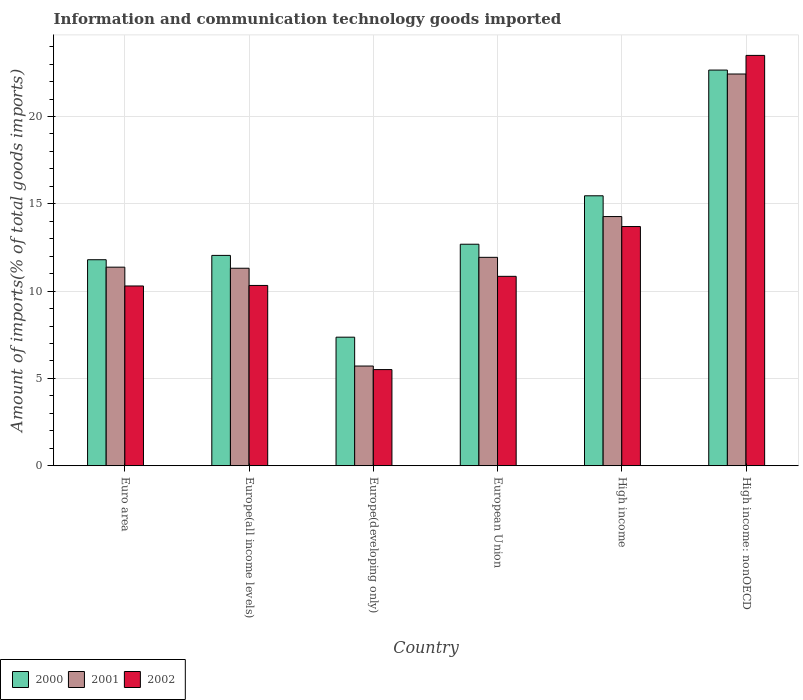How many groups of bars are there?
Provide a short and direct response. 6. Are the number of bars per tick equal to the number of legend labels?
Keep it short and to the point. Yes. Are the number of bars on each tick of the X-axis equal?
Make the answer very short. Yes. How many bars are there on the 6th tick from the right?
Offer a terse response. 3. What is the label of the 5th group of bars from the left?
Your answer should be compact. High income. In how many cases, is the number of bars for a given country not equal to the number of legend labels?
Your answer should be very brief. 0. What is the amount of goods imported in 2001 in High income: nonOECD?
Keep it short and to the point. 22.43. Across all countries, what is the maximum amount of goods imported in 2000?
Your response must be concise. 22.66. Across all countries, what is the minimum amount of goods imported in 2001?
Your answer should be very brief. 5.71. In which country was the amount of goods imported in 2000 maximum?
Offer a very short reply. High income: nonOECD. In which country was the amount of goods imported in 2000 minimum?
Your answer should be compact. Europe(developing only). What is the total amount of goods imported in 2002 in the graph?
Keep it short and to the point. 74.17. What is the difference between the amount of goods imported in 2000 in Euro area and that in Europe(all income levels)?
Give a very brief answer. -0.25. What is the difference between the amount of goods imported in 2001 in European Union and the amount of goods imported in 2000 in Europe(developing only)?
Offer a terse response. 4.57. What is the average amount of goods imported in 2000 per country?
Offer a terse response. 13.67. What is the difference between the amount of goods imported of/in 2001 and amount of goods imported of/in 2002 in Euro area?
Provide a succinct answer. 1.08. What is the ratio of the amount of goods imported in 2001 in Europe(developing only) to that in High income?
Provide a short and direct response. 0.4. Is the difference between the amount of goods imported in 2001 in Europe(all income levels) and High income greater than the difference between the amount of goods imported in 2002 in Europe(all income levels) and High income?
Offer a very short reply. Yes. What is the difference between the highest and the second highest amount of goods imported in 2001?
Your answer should be very brief. -10.5. What is the difference between the highest and the lowest amount of goods imported in 2000?
Offer a very short reply. 15.3. What does the 2nd bar from the left in High income: nonOECD represents?
Your response must be concise. 2001. Is it the case that in every country, the sum of the amount of goods imported in 2002 and amount of goods imported in 2000 is greater than the amount of goods imported in 2001?
Provide a succinct answer. Yes. Are all the bars in the graph horizontal?
Offer a terse response. No. What is the difference between two consecutive major ticks on the Y-axis?
Offer a terse response. 5. Does the graph contain grids?
Keep it short and to the point. Yes. Where does the legend appear in the graph?
Provide a short and direct response. Bottom left. How many legend labels are there?
Give a very brief answer. 3. How are the legend labels stacked?
Make the answer very short. Horizontal. What is the title of the graph?
Provide a short and direct response. Information and communication technology goods imported. What is the label or title of the Y-axis?
Give a very brief answer. Amount of imports(% of total goods imports). What is the Amount of imports(% of total goods imports) of 2000 in Euro area?
Offer a very short reply. 11.8. What is the Amount of imports(% of total goods imports) of 2001 in Euro area?
Your answer should be very brief. 11.37. What is the Amount of imports(% of total goods imports) in 2002 in Euro area?
Provide a succinct answer. 10.29. What is the Amount of imports(% of total goods imports) in 2000 in Europe(all income levels)?
Ensure brevity in your answer.  12.04. What is the Amount of imports(% of total goods imports) of 2001 in Europe(all income levels)?
Offer a very short reply. 11.31. What is the Amount of imports(% of total goods imports) of 2002 in Europe(all income levels)?
Your response must be concise. 10.32. What is the Amount of imports(% of total goods imports) in 2000 in Europe(developing only)?
Ensure brevity in your answer.  7.36. What is the Amount of imports(% of total goods imports) in 2001 in Europe(developing only)?
Make the answer very short. 5.71. What is the Amount of imports(% of total goods imports) of 2002 in Europe(developing only)?
Make the answer very short. 5.51. What is the Amount of imports(% of total goods imports) of 2000 in European Union?
Make the answer very short. 12.68. What is the Amount of imports(% of total goods imports) of 2001 in European Union?
Provide a short and direct response. 11.93. What is the Amount of imports(% of total goods imports) of 2002 in European Union?
Provide a succinct answer. 10.85. What is the Amount of imports(% of total goods imports) of 2000 in High income?
Your answer should be very brief. 15.46. What is the Amount of imports(% of total goods imports) in 2001 in High income?
Offer a very short reply. 14.27. What is the Amount of imports(% of total goods imports) in 2002 in High income?
Your answer should be compact. 13.7. What is the Amount of imports(% of total goods imports) of 2000 in High income: nonOECD?
Make the answer very short. 22.66. What is the Amount of imports(% of total goods imports) of 2001 in High income: nonOECD?
Offer a very short reply. 22.43. What is the Amount of imports(% of total goods imports) of 2002 in High income: nonOECD?
Provide a short and direct response. 23.5. Across all countries, what is the maximum Amount of imports(% of total goods imports) in 2000?
Your answer should be very brief. 22.66. Across all countries, what is the maximum Amount of imports(% of total goods imports) of 2001?
Your answer should be very brief. 22.43. Across all countries, what is the maximum Amount of imports(% of total goods imports) of 2002?
Ensure brevity in your answer.  23.5. Across all countries, what is the minimum Amount of imports(% of total goods imports) of 2000?
Provide a short and direct response. 7.36. Across all countries, what is the minimum Amount of imports(% of total goods imports) in 2001?
Make the answer very short. 5.71. Across all countries, what is the minimum Amount of imports(% of total goods imports) in 2002?
Keep it short and to the point. 5.51. What is the total Amount of imports(% of total goods imports) of 2000 in the graph?
Ensure brevity in your answer.  82.01. What is the total Amount of imports(% of total goods imports) of 2001 in the graph?
Make the answer very short. 77.03. What is the total Amount of imports(% of total goods imports) of 2002 in the graph?
Your answer should be very brief. 74.17. What is the difference between the Amount of imports(% of total goods imports) in 2000 in Euro area and that in Europe(all income levels)?
Ensure brevity in your answer.  -0.25. What is the difference between the Amount of imports(% of total goods imports) in 2001 in Euro area and that in Europe(all income levels)?
Your answer should be compact. 0.06. What is the difference between the Amount of imports(% of total goods imports) in 2002 in Euro area and that in Europe(all income levels)?
Ensure brevity in your answer.  -0.03. What is the difference between the Amount of imports(% of total goods imports) in 2000 in Euro area and that in Europe(developing only)?
Your answer should be very brief. 4.44. What is the difference between the Amount of imports(% of total goods imports) of 2001 in Euro area and that in Europe(developing only)?
Offer a very short reply. 5.66. What is the difference between the Amount of imports(% of total goods imports) in 2002 in Euro area and that in Europe(developing only)?
Your answer should be very brief. 4.79. What is the difference between the Amount of imports(% of total goods imports) in 2000 in Euro area and that in European Union?
Your answer should be very brief. -0.89. What is the difference between the Amount of imports(% of total goods imports) in 2001 in Euro area and that in European Union?
Offer a terse response. -0.56. What is the difference between the Amount of imports(% of total goods imports) of 2002 in Euro area and that in European Union?
Give a very brief answer. -0.55. What is the difference between the Amount of imports(% of total goods imports) of 2000 in Euro area and that in High income?
Keep it short and to the point. -3.66. What is the difference between the Amount of imports(% of total goods imports) of 2001 in Euro area and that in High income?
Give a very brief answer. -2.9. What is the difference between the Amount of imports(% of total goods imports) of 2002 in Euro area and that in High income?
Your response must be concise. -3.4. What is the difference between the Amount of imports(% of total goods imports) of 2000 in Euro area and that in High income: nonOECD?
Keep it short and to the point. -10.86. What is the difference between the Amount of imports(% of total goods imports) in 2001 in Euro area and that in High income: nonOECD?
Make the answer very short. -11.06. What is the difference between the Amount of imports(% of total goods imports) in 2002 in Euro area and that in High income: nonOECD?
Keep it short and to the point. -13.2. What is the difference between the Amount of imports(% of total goods imports) in 2000 in Europe(all income levels) and that in Europe(developing only)?
Make the answer very short. 4.68. What is the difference between the Amount of imports(% of total goods imports) in 2001 in Europe(all income levels) and that in Europe(developing only)?
Give a very brief answer. 5.6. What is the difference between the Amount of imports(% of total goods imports) of 2002 in Europe(all income levels) and that in Europe(developing only)?
Ensure brevity in your answer.  4.82. What is the difference between the Amount of imports(% of total goods imports) in 2000 in Europe(all income levels) and that in European Union?
Your answer should be compact. -0.64. What is the difference between the Amount of imports(% of total goods imports) of 2001 in Europe(all income levels) and that in European Union?
Provide a short and direct response. -0.62. What is the difference between the Amount of imports(% of total goods imports) in 2002 in Europe(all income levels) and that in European Union?
Offer a terse response. -0.52. What is the difference between the Amount of imports(% of total goods imports) of 2000 in Europe(all income levels) and that in High income?
Give a very brief answer. -3.41. What is the difference between the Amount of imports(% of total goods imports) in 2001 in Europe(all income levels) and that in High income?
Offer a terse response. -2.96. What is the difference between the Amount of imports(% of total goods imports) in 2002 in Europe(all income levels) and that in High income?
Offer a terse response. -3.37. What is the difference between the Amount of imports(% of total goods imports) in 2000 in Europe(all income levels) and that in High income: nonOECD?
Offer a terse response. -10.61. What is the difference between the Amount of imports(% of total goods imports) in 2001 in Europe(all income levels) and that in High income: nonOECD?
Offer a terse response. -11.12. What is the difference between the Amount of imports(% of total goods imports) of 2002 in Europe(all income levels) and that in High income: nonOECD?
Your answer should be compact. -13.17. What is the difference between the Amount of imports(% of total goods imports) of 2000 in Europe(developing only) and that in European Union?
Your response must be concise. -5.32. What is the difference between the Amount of imports(% of total goods imports) in 2001 in Europe(developing only) and that in European Union?
Provide a succinct answer. -6.22. What is the difference between the Amount of imports(% of total goods imports) of 2002 in Europe(developing only) and that in European Union?
Provide a short and direct response. -5.34. What is the difference between the Amount of imports(% of total goods imports) of 2000 in Europe(developing only) and that in High income?
Provide a short and direct response. -8.1. What is the difference between the Amount of imports(% of total goods imports) in 2001 in Europe(developing only) and that in High income?
Your answer should be very brief. -8.56. What is the difference between the Amount of imports(% of total goods imports) in 2002 in Europe(developing only) and that in High income?
Offer a very short reply. -8.19. What is the difference between the Amount of imports(% of total goods imports) of 2000 in Europe(developing only) and that in High income: nonOECD?
Provide a succinct answer. -15.3. What is the difference between the Amount of imports(% of total goods imports) in 2001 in Europe(developing only) and that in High income: nonOECD?
Your response must be concise. -16.72. What is the difference between the Amount of imports(% of total goods imports) of 2002 in Europe(developing only) and that in High income: nonOECD?
Offer a very short reply. -17.99. What is the difference between the Amount of imports(% of total goods imports) of 2000 in European Union and that in High income?
Keep it short and to the point. -2.77. What is the difference between the Amount of imports(% of total goods imports) of 2001 in European Union and that in High income?
Provide a succinct answer. -2.34. What is the difference between the Amount of imports(% of total goods imports) of 2002 in European Union and that in High income?
Your response must be concise. -2.85. What is the difference between the Amount of imports(% of total goods imports) of 2000 in European Union and that in High income: nonOECD?
Your answer should be very brief. -9.97. What is the difference between the Amount of imports(% of total goods imports) of 2001 in European Union and that in High income: nonOECD?
Offer a terse response. -10.5. What is the difference between the Amount of imports(% of total goods imports) in 2002 in European Union and that in High income: nonOECD?
Make the answer very short. -12.65. What is the difference between the Amount of imports(% of total goods imports) in 2000 in High income and that in High income: nonOECD?
Give a very brief answer. -7.2. What is the difference between the Amount of imports(% of total goods imports) in 2001 in High income and that in High income: nonOECD?
Offer a very short reply. -8.16. What is the difference between the Amount of imports(% of total goods imports) in 2002 in High income and that in High income: nonOECD?
Make the answer very short. -9.8. What is the difference between the Amount of imports(% of total goods imports) in 2000 in Euro area and the Amount of imports(% of total goods imports) in 2001 in Europe(all income levels)?
Offer a very short reply. 0.49. What is the difference between the Amount of imports(% of total goods imports) of 2000 in Euro area and the Amount of imports(% of total goods imports) of 2002 in Europe(all income levels)?
Give a very brief answer. 1.47. What is the difference between the Amount of imports(% of total goods imports) of 2001 in Euro area and the Amount of imports(% of total goods imports) of 2002 in Europe(all income levels)?
Your answer should be very brief. 1.05. What is the difference between the Amount of imports(% of total goods imports) in 2000 in Euro area and the Amount of imports(% of total goods imports) in 2001 in Europe(developing only)?
Keep it short and to the point. 6.09. What is the difference between the Amount of imports(% of total goods imports) in 2000 in Euro area and the Amount of imports(% of total goods imports) in 2002 in Europe(developing only)?
Make the answer very short. 6.29. What is the difference between the Amount of imports(% of total goods imports) in 2001 in Euro area and the Amount of imports(% of total goods imports) in 2002 in Europe(developing only)?
Provide a succinct answer. 5.87. What is the difference between the Amount of imports(% of total goods imports) in 2000 in Euro area and the Amount of imports(% of total goods imports) in 2001 in European Union?
Your response must be concise. -0.14. What is the difference between the Amount of imports(% of total goods imports) of 2000 in Euro area and the Amount of imports(% of total goods imports) of 2002 in European Union?
Your answer should be compact. 0.95. What is the difference between the Amount of imports(% of total goods imports) in 2001 in Euro area and the Amount of imports(% of total goods imports) in 2002 in European Union?
Offer a very short reply. 0.53. What is the difference between the Amount of imports(% of total goods imports) in 2000 in Euro area and the Amount of imports(% of total goods imports) in 2001 in High income?
Provide a succinct answer. -2.47. What is the difference between the Amount of imports(% of total goods imports) of 2000 in Euro area and the Amount of imports(% of total goods imports) of 2002 in High income?
Provide a short and direct response. -1.9. What is the difference between the Amount of imports(% of total goods imports) of 2001 in Euro area and the Amount of imports(% of total goods imports) of 2002 in High income?
Your response must be concise. -2.33. What is the difference between the Amount of imports(% of total goods imports) of 2000 in Euro area and the Amount of imports(% of total goods imports) of 2001 in High income: nonOECD?
Give a very brief answer. -10.64. What is the difference between the Amount of imports(% of total goods imports) in 2000 in Euro area and the Amount of imports(% of total goods imports) in 2002 in High income: nonOECD?
Your response must be concise. -11.7. What is the difference between the Amount of imports(% of total goods imports) of 2001 in Euro area and the Amount of imports(% of total goods imports) of 2002 in High income: nonOECD?
Make the answer very short. -12.13. What is the difference between the Amount of imports(% of total goods imports) of 2000 in Europe(all income levels) and the Amount of imports(% of total goods imports) of 2001 in Europe(developing only)?
Make the answer very short. 6.34. What is the difference between the Amount of imports(% of total goods imports) in 2000 in Europe(all income levels) and the Amount of imports(% of total goods imports) in 2002 in Europe(developing only)?
Make the answer very short. 6.54. What is the difference between the Amount of imports(% of total goods imports) of 2001 in Europe(all income levels) and the Amount of imports(% of total goods imports) of 2002 in Europe(developing only)?
Make the answer very short. 5.8. What is the difference between the Amount of imports(% of total goods imports) of 2000 in Europe(all income levels) and the Amount of imports(% of total goods imports) of 2001 in European Union?
Keep it short and to the point. 0.11. What is the difference between the Amount of imports(% of total goods imports) of 2000 in Europe(all income levels) and the Amount of imports(% of total goods imports) of 2002 in European Union?
Ensure brevity in your answer.  1.2. What is the difference between the Amount of imports(% of total goods imports) in 2001 in Europe(all income levels) and the Amount of imports(% of total goods imports) in 2002 in European Union?
Your answer should be very brief. 0.46. What is the difference between the Amount of imports(% of total goods imports) in 2000 in Europe(all income levels) and the Amount of imports(% of total goods imports) in 2001 in High income?
Offer a very short reply. -2.22. What is the difference between the Amount of imports(% of total goods imports) of 2000 in Europe(all income levels) and the Amount of imports(% of total goods imports) of 2002 in High income?
Keep it short and to the point. -1.65. What is the difference between the Amount of imports(% of total goods imports) of 2001 in Europe(all income levels) and the Amount of imports(% of total goods imports) of 2002 in High income?
Your answer should be compact. -2.39. What is the difference between the Amount of imports(% of total goods imports) of 2000 in Europe(all income levels) and the Amount of imports(% of total goods imports) of 2001 in High income: nonOECD?
Your answer should be compact. -10.39. What is the difference between the Amount of imports(% of total goods imports) of 2000 in Europe(all income levels) and the Amount of imports(% of total goods imports) of 2002 in High income: nonOECD?
Your answer should be compact. -11.45. What is the difference between the Amount of imports(% of total goods imports) of 2001 in Europe(all income levels) and the Amount of imports(% of total goods imports) of 2002 in High income: nonOECD?
Your answer should be very brief. -12.19. What is the difference between the Amount of imports(% of total goods imports) of 2000 in Europe(developing only) and the Amount of imports(% of total goods imports) of 2001 in European Union?
Offer a terse response. -4.57. What is the difference between the Amount of imports(% of total goods imports) in 2000 in Europe(developing only) and the Amount of imports(% of total goods imports) in 2002 in European Union?
Make the answer very short. -3.48. What is the difference between the Amount of imports(% of total goods imports) of 2001 in Europe(developing only) and the Amount of imports(% of total goods imports) of 2002 in European Union?
Keep it short and to the point. -5.14. What is the difference between the Amount of imports(% of total goods imports) in 2000 in Europe(developing only) and the Amount of imports(% of total goods imports) in 2001 in High income?
Offer a terse response. -6.91. What is the difference between the Amount of imports(% of total goods imports) of 2000 in Europe(developing only) and the Amount of imports(% of total goods imports) of 2002 in High income?
Give a very brief answer. -6.34. What is the difference between the Amount of imports(% of total goods imports) in 2001 in Europe(developing only) and the Amount of imports(% of total goods imports) in 2002 in High income?
Offer a terse response. -7.99. What is the difference between the Amount of imports(% of total goods imports) in 2000 in Europe(developing only) and the Amount of imports(% of total goods imports) in 2001 in High income: nonOECD?
Make the answer very short. -15.07. What is the difference between the Amount of imports(% of total goods imports) of 2000 in Europe(developing only) and the Amount of imports(% of total goods imports) of 2002 in High income: nonOECD?
Your answer should be very brief. -16.14. What is the difference between the Amount of imports(% of total goods imports) of 2001 in Europe(developing only) and the Amount of imports(% of total goods imports) of 2002 in High income: nonOECD?
Offer a very short reply. -17.79. What is the difference between the Amount of imports(% of total goods imports) of 2000 in European Union and the Amount of imports(% of total goods imports) of 2001 in High income?
Give a very brief answer. -1.59. What is the difference between the Amount of imports(% of total goods imports) in 2000 in European Union and the Amount of imports(% of total goods imports) in 2002 in High income?
Your answer should be very brief. -1.01. What is the difference between the Amount of imports(% of total goods imports) of 2001 in European Union and the Amount of imports(% of total goods imports) of 2002 in High income?
Provide a succinct answer. -1.76. What is the difference between the Amount of imports(% of total goods imports) in 2000 in European Union and the Amount of imports(% of total goods imports) in 2001 in High income: nonOECD?
Keep it short and to the point. -9.75. What is the difference between the Amount of imports(% of total goods imports) of 2000 in European Union and the Amount of imports(% of total goods imports) of 2002 in High income: nonOECD?
Your answer should be compact. -10.81. What is the difference between the Amount of imports(% of total goods imports) of 2001 in European Union and the Amount of imports(% of total goods imports) of 2002 in High income: nonOECD?
Give a very brief answer. -11.56. What is the difference between the Amount of imports(% of total goods imports) in 2000 in High income and the Amount of imports(% of total goods imports) in 2001 in High income: nonOECD?
Your answer should be very brief. -6.97. What is the difference between the Amount of imports(% of total goods imports) of 2000 in High income and the Amount of imports(% of total goods imports) of 2002 in High income: nonOECD?
Your answer should be compact. -8.04. What is the difference between the Amount of imports(% of total goods imports) in 2001 in High income and the Amount of imports(% of total goods imports) in 2002 in High income: nonOECD?
Your answer should be very brief. -9.23. What is the average Amount of imports(% of total goods imports) of 2000 per country?
Provide a succinct answer. 13.67. What is the average Amount of imports(% of total goods imports) of 2001 per country?
Your answer should be very brief. 12.84. What is the average Amount of imports(% of total goods imports) in 2002 per country?
Ensure brevity in your answer.  12.36. What is the difference between the Amount of imports(% of total goods imports) in 2000 and Amount of imports(% of total goods imports) in 2001 in Euro area?
Keep it short and to the point. 0.43. What is the difference between the Amount of imports(% of total goods imports) in 2000 and Amount of imports(% of total goods imports) in 2002 in Euro area?
Your answer should be very brief. 1.5. What is the difference between the Amount of imports(% of total goods imports) of 2001 and Amount of imports(% of total goods imports) of 2002 in Euro area?
Provide a short and direct response. 1.08. What is the difference between the Amount of imports(% of total goods imports) in 2000 and Amount of imports(% of total goods imports) in 2001 in Europe(all income levels)?
Ensure brevity in your answer.  0.74. What is the difference between the Amount of imports(% of total goods imports) in 2000 and Amount of imports(% of total goods imports) in 2002 in Europe(all income levels)?
Keep it short and to the point. 1.72. What is the difference between the Amount of imports(% of total goods imports) of 2000 and Amount of imports(% of total goods imports) of 2001 in Europe(developing only)?
Your response must be concise. 1.65. What is the difference between the Amount of imports(% of total goods imports) of 2000 and Amount of imports(% of total goods imports) of 2002 in Europe(developing only)?
Offer a very short reply. 1.86. What is the difference between the Amount of imports(% of total goods imports) in 2001 and Amount of imports(% of total goods imports) in 2002 in Europe(developing only)?
Provide a succinct answer. 0.2. What is the difference between the Amount of imports(% of total goods imports) of 2000 and Amount of imports(% of total goods imports) of 2001 in European Union?
Provide a succinct answer. 0.75. What is the difference between the Amount of imports(% of total goods imports) of 2000 and Amount of imports(% of total goods imports) of 2002 in European Union?
Offer a terse response. 1.84. What is the difference between the Amount of imports(% of total goods imports) in 2001 and Amount of imports(% of total goods imports) in 2002 in European Union?
Your response must be concise. 1.09. What is the difference between the Amount of imports(% of total goods imports) of 2000 and Amount of imports(% of total goods imports) of 2001 in High income?
Offer a terse response. 1.19. What is the difference between the Amount of imports(% of total goods imports) in 2000 and Amount of imports(% of total goods imports) in 2002 in High income?
Give a very brief answer. 1.76. What is the difference between the Amount of imports(% of total goods imports) in 2001 and Amount of imports(% of total goods imports) in 2002 in High income?
Offer a terse response. 0.57. What is the difference between the Amount of imports(% of total goods imports) of 2000 and Amount of imports(% of total goods imports) of 2001 in High income: nonOECD?
Make the answer very short. 0.23. What is the difference between the Amount of imports(% of total goods imports) in 2000 and Amount of imports(% of total goods imports) in 2002 in High income: nonOECD?
Offer a terse response. -0.84. What is the difference between the Amount of imports(% of total goods imports) in 2001 and Amount of imports(% of total goods imports) in 2002 in High income: nonOECD?
Your answer should be compact. -1.07. What is the ratio of the Amount of imports(% of total goods imports) of 2000 in Euro area to that in Europe(all income levels)?
Provide a succinct answer. 0.98. What is the ratio of the Amount of imports(% of total goods imports) in 2002 in Euro area to that in Europe(all income levels)?
Your answer should be compact. 1. What is the ratio of the Amount of imports(% of total goods imports) in 2000 in Euro area to that in Europe(developing only)?
Make the answer very short. 1.6. What is the ratio of the Amount of imports(% of total goods imports) in 2001 in Euro area to that in Europe(developing only)?
Ensure brevity in your answer.  1.99. What is the ratio of the Amount of imports(% of total goods imports) in 2002 in Euro area to that in Europe(developing only)?
Offer a very short reply. 1.87. What is the ratio of the Amount of imports(% of total goods imports) in 2000 in Euro area to that in European Union?
Your answer should be compact. 0.93. What is the ratio of the Amount of imports(% of total goods imports) in 2001 in Euro area to that in European Union?
Offer a terse response. 0.95. What is the ratio of the Amount of imports(% of total goods imports) in 2002 in Euro area to that in European Union?
Your response must be concise. 0.95. What is the ratio of the Amount of imports(% of total goods imports) of 2000 in Euro area to that in High income?
Your answer should be compact. 0.76. What is the ratio of the Amount of imports(% of total goods imports) of 2001 in Euro area to that in High income?
Keep it short and to the point. 0.8. What is the ratio of the Amount of imports(% of total goods imports) of 2002 in Euro area to that in High income?
Provide a short and direct response. 0.75. What is the ratio of the Amount of imports(% of total goods imports) in 2000 in Euro area to that in High income: nonOECD?
Provide a short and direct response. 0.52. What is the ratio of the Amount of imports(% of total goods imports) of 2001 in Euro area to that in High income: nonOECD?
Your answer should be very brief. 0.51. What is the ratio of the Amount of imports(% of total goods imports) in 2002 in Euro area to that in High income: nonOECD?
Ensure brevity in your answer.  0.44. What is the ratio of the Amount of imports(% of total goods imports) of 2000 in Europe(all income levels) to that in Europe(developing only)?
Your answer should be compact. 1.64. What is the ratio of the Amount of imports(% of total goods imports) in 2001 in Europe(all income levels) to that in Europe(developing only)?
Offer a terse response. 1.98. What is the ratio of the Amount of imports(% of total goods imports) of 2002 in Europe(all income levels) to that in Europe(developing only)?
Offer a terse response. 1.88. What is the ratio of the Amount of imports(% of total goods imports) in 2000 in Europe(all income levels) to that in European Union?
Give a very brief answer. 0.95. What is the ratio of the Amount of imports(% of total goods imports) in 2001 in Europe(all income levels) to that in European Union?
Provide a succinct answer. 0.95. What is the ratio of the Amount of imports(% of total goods imports) of 2002 in Europe(all income levels) to that in European Union?
Give a very brief answer. 0.95. What is the ratio of the Amount of imports(% of total goods imports) of 2000 in Europe(all income levels) to that in High income?
Your response must be concise. 0.78. What is the ratio of the Amount of imports(% of total goods imports) of 2001 in Europe(all income levels) to that in High income?
Your answer should be compact. 0.79. What is the ratio of the Amount of imports(% of total goods imports) of 2002 in Europe(all income levels) to that in High income?
Offer a terse response. 0.75. What is the ratio of the Amount of imports(% of total goods imports) of 2000 in Europe(all income levels) to that in High income: nonOECD?
Your answer should be compact. 0.53. What is the ratio of the Amount of imports(% of total goods imports) of 2001 in Europe(all income levels) to that in High income: nonOECD?
Your answer should be compact. 0.5. What is the ratio of the Amount of imports(% of total goods imports) of 2002 in Europe(all income levels) to that in High income: nonOECD?
Ensure brevity in your answer.  0.44. What is the ratio of the Amount of imports(% of total goods imports) of 2000 in Europe(developing only) to that in European Union?
Give a very brief answer. 0.58. What is the ratio of the Amount of imports(% of total goods imports) in 2001 in Europe(developing only) to that in European Union?
Give a very brief answer. 0.48. What is the ratio of the Amount of imports(% of total goods imports) of 2002 in Europe(developing only) to that in European Union?
Provide a short and direct response. 0.51. What is the ratio of the Amount of imports(% of total goods imports) of 2000 in Europe(developing only) to that in High income?
Provide a short and direct response. 0.48. What is the ratio of the Amount of imports(% of total goods imports) of 2001 in Europe(developing only) to that in High income?
Make the answer very short. 0.4. What is the ratio of the Amount of imports(% of total goods imports) in 2002 in Europe(developing only) to that in High income?
Your answer should be compact. 0.4. What is the ratio of the Amount of imports(% of total goods imports) in 2000 in Europe(developing only) to that in High income: nonOECD?
Keep it short and to the point. 0.32. What is the ratio of the Amount of imports(% of total goods imports) of 2001 in Europe(developing only) to that in High income: nonOECD?
Offer a very short reply. 0.25. What is the ratio of the Amount of imports(% of total goods imports) in 2002 in Europe(developing only) to that in High income: nonOECD?
Offer a very short reply. 0.23. What is the ratio of the Amount of imports(% of total goods imports) of 2000 in European Union to that in High income?
Offer a very short reply. 0.82. What is the ratio of the Amount of imports(% of total goods imports) of 2001 in European Union to that in High income?
Make the answer very short. 0.84. What is the ratio of the Amount of imports(% of total goods imports) in 2002 in European Union to that in High income?
Your answer should be very brief. 0.79. What is the ratio of the Amount of imports(% of total goods imports) in 2000 in European Union to that in High income: nonOECD?
Your answer should be compact. 0.56. What is the ratio of the Amount of imports(% of total goods imports) of 2001 in European Union to that in High income: nonOECD?
Offer a very short reply. 0.53. What is the ratio of the Amount of imports(% of total goods imports) of 2002 in European Union to that in High income: nonOECD?
Give a very brief answer. 0.46. What is the ratio of the Amount of imports(% of total goods imports) of 2000 in High income to that in High income: nonOECD?
Offer a very short reply. 0.68. What is the ratio of the Amount of imports(% of total goods imports) in 2001 in High income to that in High income: nonOECD?
Make the answer very short. 0.64. What is the ratio of the Amount of imports(% of total goods imports) of 2002 in High income to that in High income: nonOECD?
Make the answer very short. 0.58. What is the difference between the highest and the second highest Amount of imports(% of total goods imports) of 2000?
Ensure brevity in your answer.  7.2. What is the difference between the highest and the second highest Amount of imports(% of total goods imports) in 2001?
Provide a short and direct response. 8.16. What is the difference between the highest and the second highest Amount of imports(% of total goods imports) of 2002?
Make the answer very short. 9.8. What is the difference between the highest and the lowest Amount of imports(% of total goods imports) in 2000?
Your response must be concise. 15.3. What is the difference between the highest and the lowest Amount of imports(% of total goods imports) of 2001?
Provide a succinct answer. 16.72. What is the difference between the highest and the lowest Amount of imports(% of total goods imports) of 2002?
Give a very brief answer. 17.99. 